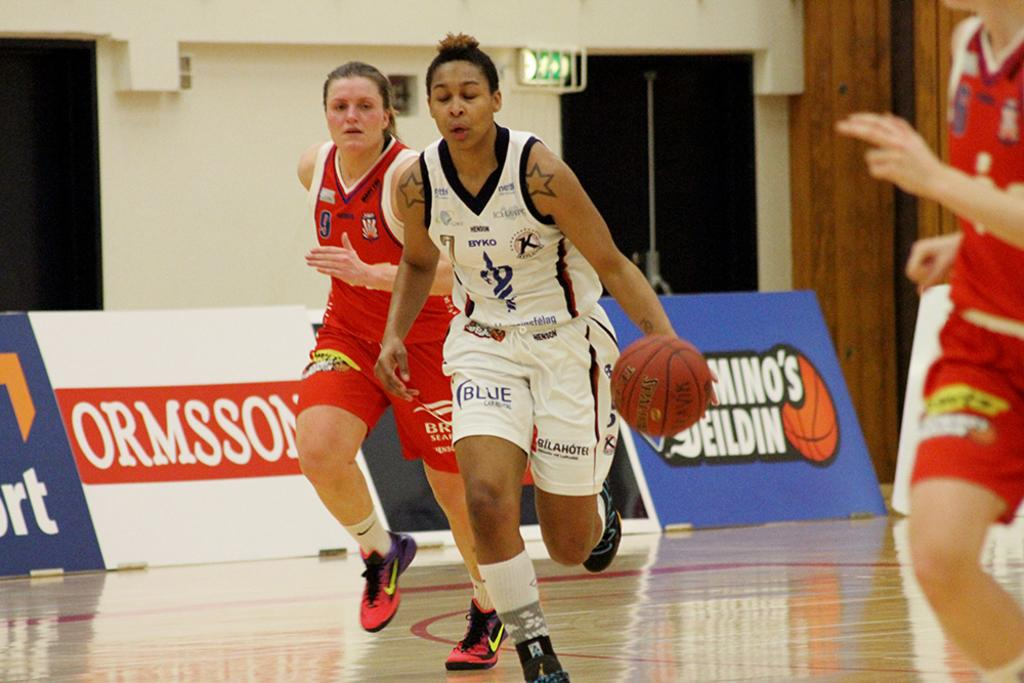<image>
Write a terse but informative summary of the picture. a sign that has the words ormsson on it 